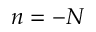Convert formula to latex. <formula><loc_0><loc_0><loc_500><loc_500>n = - N</formula> 